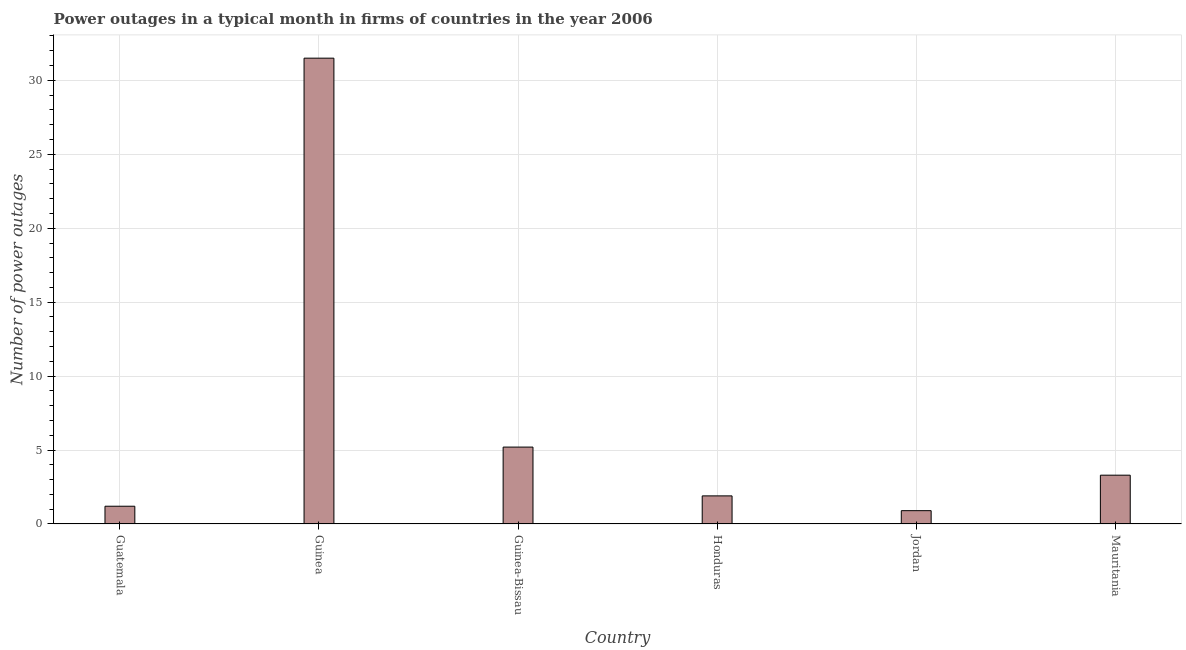What is the title of the graph?
Your answer should be very brief. Power outages in a typical month in firms of countries in the year 2006. What is the label or title of the X-axis?
Your answer should be very brief. Country. What is the label or title of the Y-axis?
Give a very brief answer. Number of power outages. What is the number of power outages in Guinea?
Your response must be concise. 31.5. Across all countries, what is the maximum number of power outages?
Ensure brevity in your answer.  31.5. Across all countries, what is the minimum number of power outages?
Offer a terse response. 0.9. In which country was the number of power outages maximum?
Your answer should be very brief. Guinea. In which country was the number of power outages minimum?
Your response must be concise. Jordan. What is the sum of the number of power outages?
Keep it short and to the point. 44. What is the average number of power outages per country?
Keep it short and to the point. 7.33. What is the median number of power outages?
Provide a short and direct response. 2.6. What is the ratio of the number of power outages in Guinea-Bissau to that in Honduras?
Your response must be concise. 2.74. Is the number of power outages in Jordan less than that in Mauritania?
Provide a succinct answer. Yes. Is the difference between the number of power outages in Guatemala and Mauritania greater than the difference between any two countries?
Keep it short and to the point. No. What is the difference between the highest and the second highest number of power outages?
Give a very brief answer. 26.3. What is the difference between the highest and the lowest number of power outages?
Provide a short and direct response. 30.6. How many countries are there in the graph?
Your answer should be very brief. 6. What is the difference between two consecutive major ticks on the Y-axis?
Give a very brief answer. 5. What is the Number of power outages in Guatemala?
Your answer should be compact. 1.2. What is the Number of power outages of Guinea?
Your answer should be very brief. 31.5. What is the Number of power outages of Guinea-Bissau?
Your answer should be very brief. 5.2. What is the difference between the Number of power outages in Guatemala and Guinea?
Give a very brief answer. -30.3. What is the difference between the Number of power outages in Guinea and Guinea-Bissau?
Your answer should be compact. 26.3. What is the difference between the Number of power outages in Guinea and Honduras?
Your answer should be very brief. 29.6. What is the difference between the Number of power outages in Guinea and Jordan?
Offer a terse response. 30.6. What is the difference between the Number of power outages in Guinea and Mauritania?
Offer a very short reply. 28.2. What is the difference between the Number of power outages in Guinea-Bissau and Honduras?
Provide a short and direct response. 3.3. What is the difference between the Number of power outages in Guinea-Bissau and Jordan?
Offer a terse response. 4.3. What is the difference between the Number of power outages in Guinea-Bissau and Mauritania?
Offer a terse response. 1.9. What is the difference between the Number of power outages in Honduras and Jordan?
Your answer should be very brief. 1. What is the difference between the Number of power outages in Honduras and Mauritania?
Provide a succinct answer. -1.4. What is the ratio of the Number of power outages in Guatemala to that in Guinea?
Make the answer very short. 0.04. What is the ratio of the Number of power outages in Guatemala to that in Guinea-Bissau?
Keep it short and to the point. 0.23. What is the ratio of the Number of power outages in Guatemala to that in Honduras?
Make the answer very short. 0.63. What is the ratio of the Number of power outages in Guatemala to that in Jordan?
Offer a very short reply. 1.33. What is the ratio of the Number of power outages in Guatemala to that in Mauritania?
Your response must be concise. 0.36. What is the ratio of the Number of power outages in Guinea to that in Guinea-Bissau?
Your response must be concise. 6.06. What is the ratio of the Number of power outages in Guinea to that in Honduras?
Give a very brief answer. 16.58. What is the ratio of the Number of power outages in Guinea to that in Mauritania?
Your answer should be very brief. 9.54. What is the ratio of the Number of power outages in Guinea-Bissau to that in Honduras?
Your answer should be compact. 2.74. What is the ratio of the Number of power outages in Guinea-Bissau to that in Jordan?
Your answer should be very brief. 5.78. What is the ratio of the Number of power outages in Guinea-Bissau to that in Mauritania?
Keep it short and to the point. 1.58. What is the ratio of the Number of power outages in Honduras to that in Jordan?
Provide a short and direct response. 2.11. What is the ratio of the Number of power outages in Honduras to that in Mauritania?
Keep it short and to the point. 0.58. What is the ratio of the Number of power outages in Jordan to that in Mauritania?
Your answer should be very brief. 0.27. 